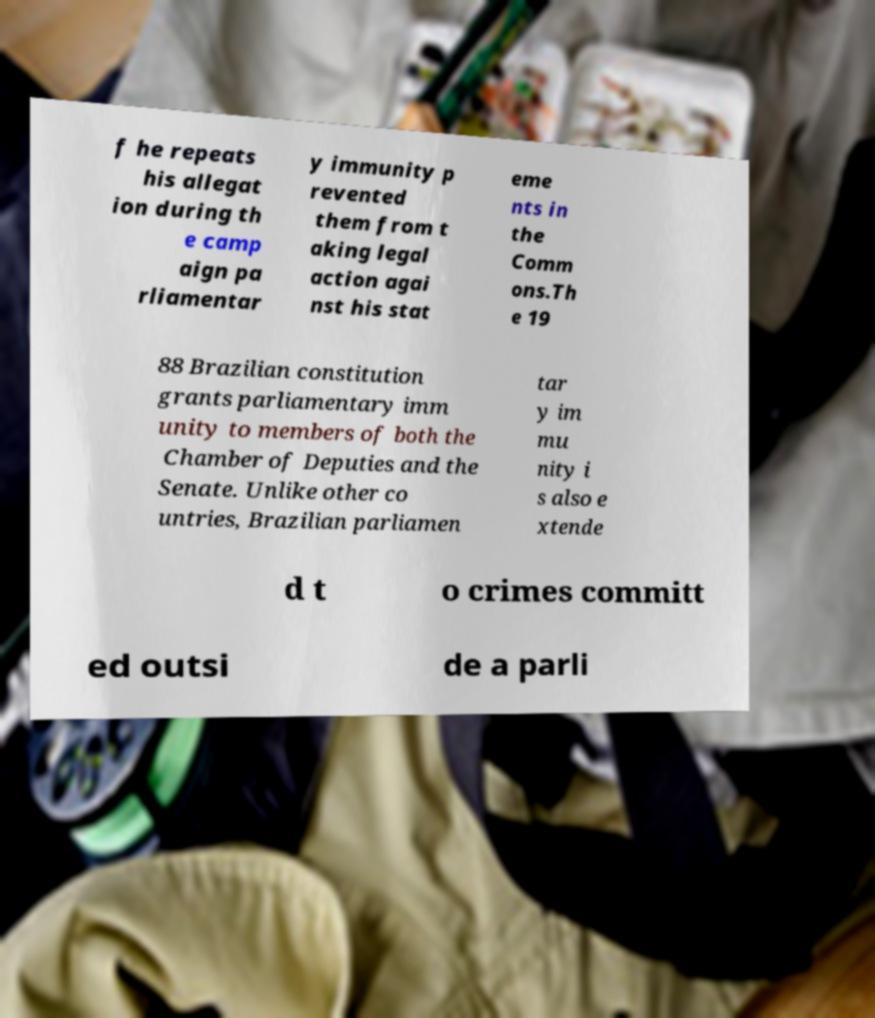Could you extract and type out the text from this image? f he repeats his allegat ion during th e camp aign pa rliamentar y immunity p revented them from t aking legal action agai nst his stat eme nts in the Comm ons.Th e 19 88 Brazilian constitution grants parliamentary imm unity to members of both the Chamber of Deputies and the Senate. Unlike other co untries, Brazilian parliamen tar y im mu nity i s also e xtende d t o crimes committ ed outsi de a parli 